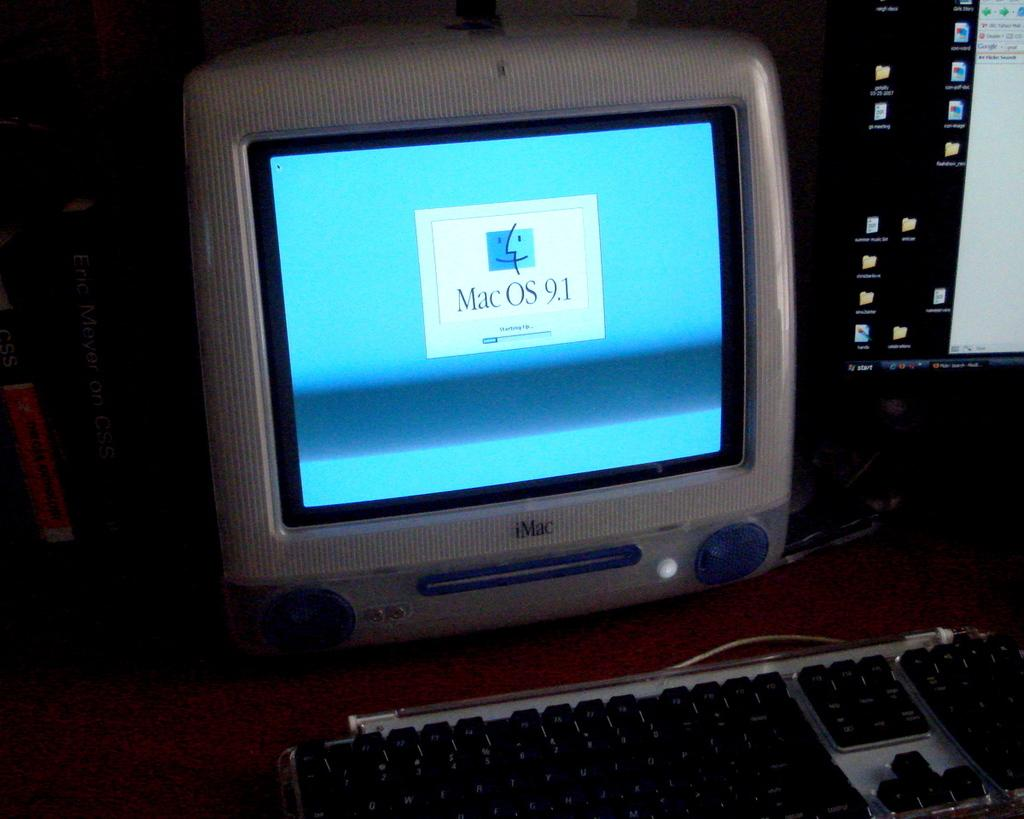<image>
Offer a succinct explanation of the picture presented. The iMac shows a screen showing Mac OS 9.1 